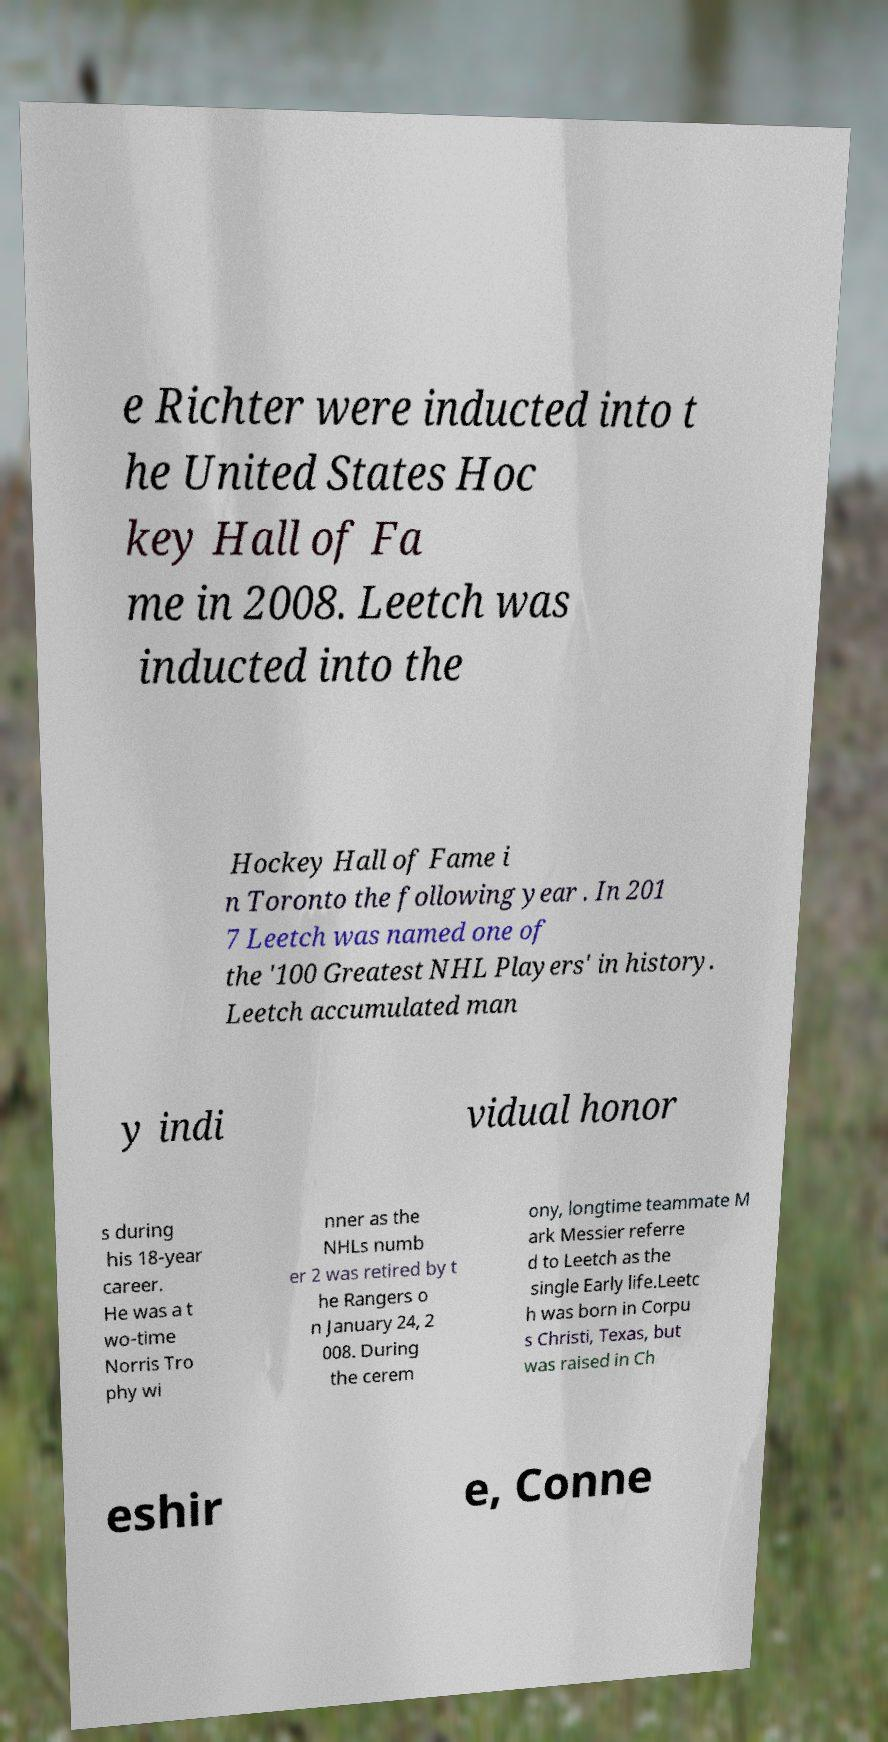Can you read and provide the text displayed in the image?This photo seems to have some interesting text. Can you extract and type it out for me? e Richter were inducted into t he United States Hoc key Hall of Fa me in 2008. Leetch was inducted into the Hockey Hall of Fame i n Toronto the following year . In 201 7 Leetch was named one of the '100 Greatest NHL Players' in history. Leetch accumulated man y indi vidual honor s during his 18-year career. He was a t wo-time Norris Tro phy wi nner as the NHLs numb er 2 was retired by t he Rangers o n January 24, 2 008. During the cerem ony, longtime teammate M ark Messier referre d to Leetch as the single Early life.Leetc h was born in Corpu s Christi, Texas, but was raised in Ch eshir e, Conne 